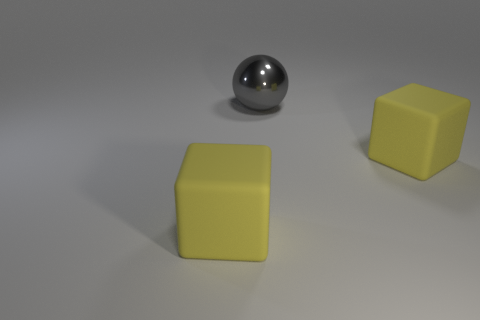Are there any rubber things that are right of the matte block that is to the right of the big matte block to the left of the large ball?
Make the answer very short. No. There is a large thing that is left of the big shiny thing; what color is it?
Make the answer very short. Yellow. How big is the gray metal object?
Ensure brevity in your answer.  Large. There is a gray object; is it the same size as the yellow object that is on the right side of the large metal object?
Give a very brief answer. Yes. What color is the matte object that is to the left of the big metallic ball behind the large object right of the large gray metallic sphere?
Provide a short and direct response. Yellow. Are the yellow object right of the shiny ball and the large sphere made of the same material?
Provide a short and direct response. No. How many other objects are the same material as the large gray sphere?
Provide a short and direct response. 0. There is a big object on the right side of the large shiny thing; is it the same shape as the matte thing to the left of the ball?
Provide a succinct answer. Yes. Is the thing to the left of the large gray shiny thing made of the same material as the large object right of the big gray object?
Your answer should be very brief. Yes. Are there any big yellow matte cubes that are on the right side of the large block right of the gray metal sphere?
Make the answer very short. No. 